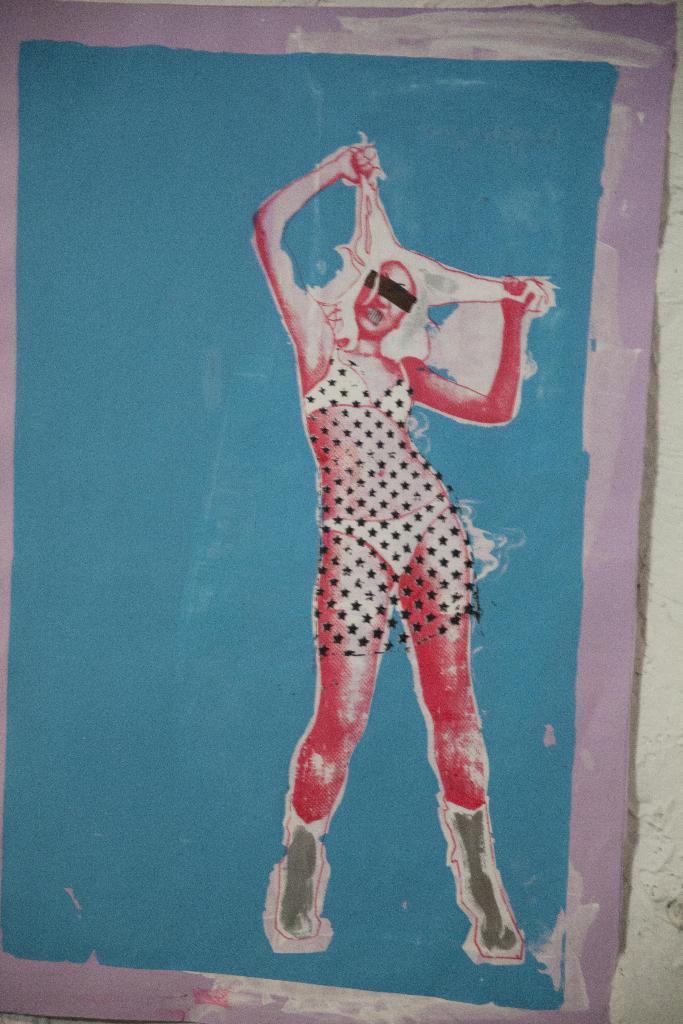How would you summarize this image in a sentence or two? In this image we can see a painting on the wall. In this painting we can see a lady. 